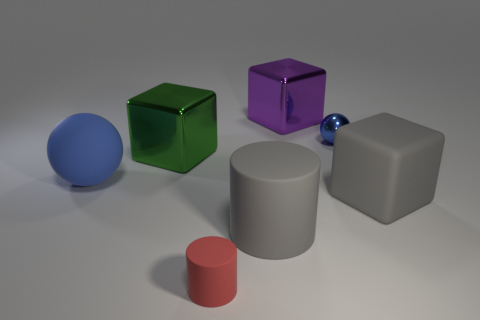Add 2 big gray rubber objects. How many objects exist? 9 Subtract all blocks. How many objects are left? 4 Subtract 0 brown cylinders. How many objects are left? 7 Subtract all blocks. Subtract all red rubber objects. How many objects are left? 3 Add 7 small blue metal things. How many small blue metal things are left? 8 Add 4 tiny red matte objects. How many tiny red matte objects exist? 5 